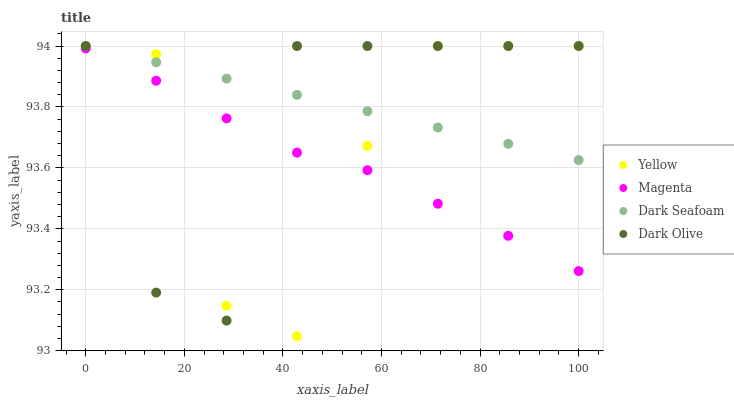Does Magenta have the minimum area under the curve?
Answer yes or no. Yes. Does Dark Seafoam have the maximum area under the curve?
Answer yes or no. Yes. Does Dark Olive have the minimum area under the curve?
Answer yes or no. No. Does Dark Olive have the maximum area under the curve?
Answer yes or no. No. Is Dark Seafoam the smoothest?
Answer yes or no. Yes. Is Yellow the roughest?
Answer yes or no. Yes. Is Dark Olive the smoothest?
Answer yes or no. No. Is Dark Olive the roughest?
Answer yes or no. No. Does Yellow have the lowest value?
Answer yes or no. Yes. Does Dark Olive have the lowest value?
Answer yes or no. No. Does Yellow have the highest value?
Answer yes or no. Yes. Is Magenta less than Dark Seafoam?
Answer yes or no. Yes. Is Dark Seafoam greater than Magenta?
Answer yes or no. Yes. Does Dark Olive intersect Magenta?
Answer yes or no. Yes. Is Dark Olive less than Magenta?
Answer yes or no. No. Is Dark Olive greater than Magenta?
Answer yes or no. No. Does Magenta intersect Dark Seafoam?
Answer yes or no. No. 